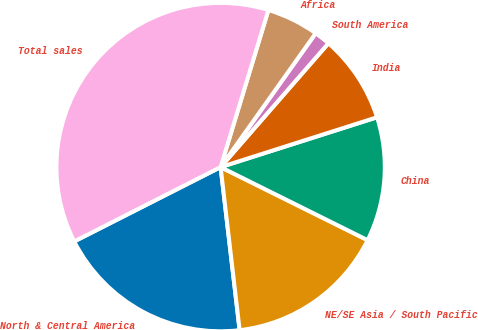<chart> <loc_0><loc_0><loc_500><loc_500><pie_chart><fcel>North & Central America<fcel>NE/SE Asia / South Pacific<fcel>China<fcel>India<fcel>South America<fcel>Africa<fcel>Total sales<nl><fcel>19.37%<fcel>15.81%<fcel>12.25%<fcel>8.69%<fcel>1.57%<fcel>5.13%<fcel>37.18%<nl></chart> 